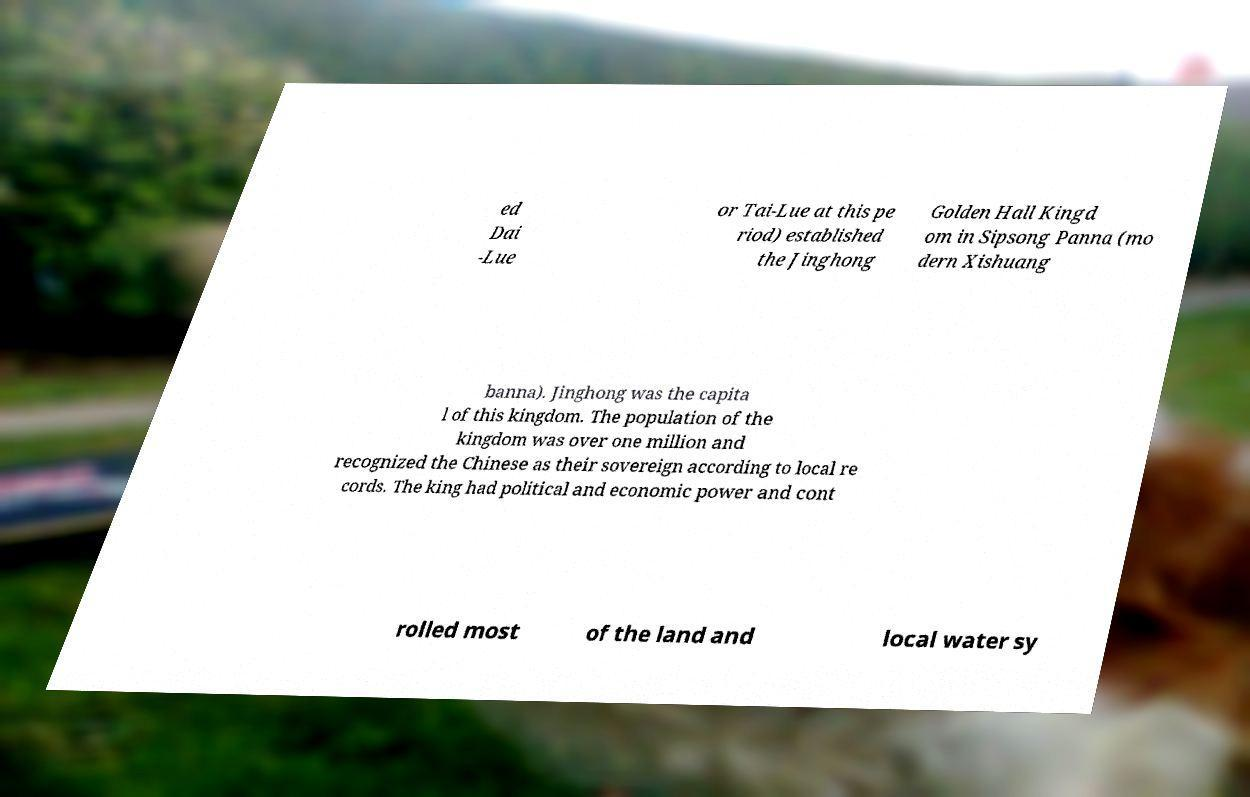Please identify and transcribe the text found in this image. ed Dai -Lue or Tai-Lue at this pe riod) established the Jinghong Golden Hall Kingd om in Sipsong Panna (mo dern Xishuang banna). Jinghong was the capita l of this kingdom. The population of the kingdom was over one million and recognized the Chinese as their sovereign according to local re cords. The king had political and economic power and cont rolled most of the land and local water sy 